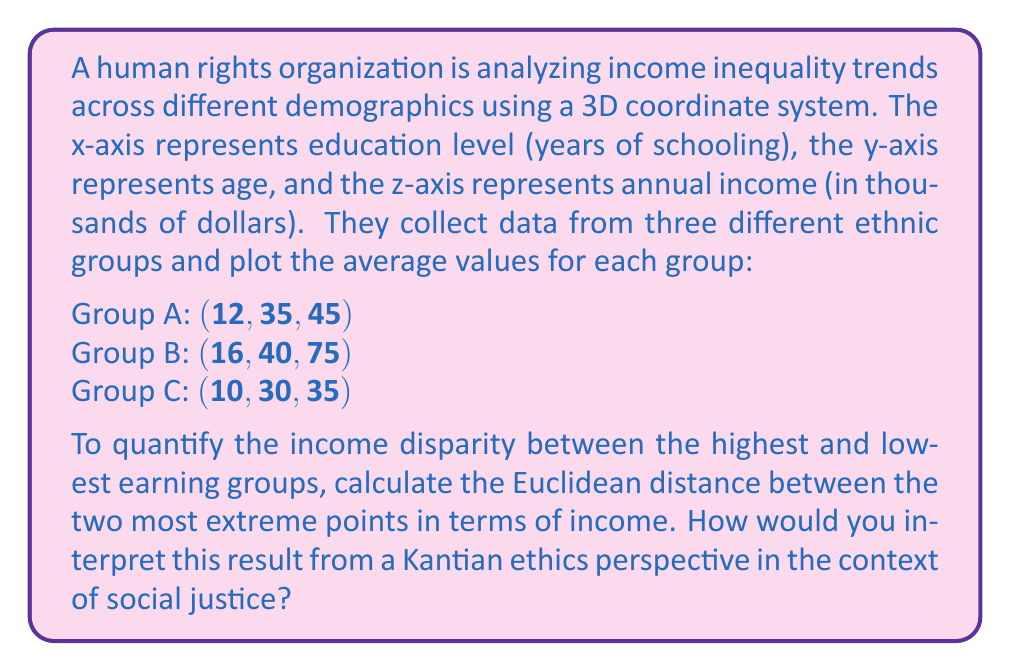Provide a solution to this math problem. To solve this problem, we need to follow these steps:

1. Identify the two most extreme points in terms of income (z-axis).
2. Calculate the Euclidean distance between these points.
3. Interpret the result from a Kantian ethics perspective.

Step 1: Identifying the extreme points
The highest income is for Group B at $75,000, and the lowest is for Group C at $35,000.

Step 2: Calculating the Euclidean distance
The Euclidean distance in 3D space is given by the formula:

$$d = \sqrt{(x_2-x_1)^2 + (y_2-y_1)^2 + (z_2-z_1)^2}$$

Where $(x_1, y_1, z_1)$ is the first point and $(x_2, y_2, z_2)$ is the second point.

Substituting the values:
$$(x_1, y_1, z_1) = (10, 30, 35)$$ (Group C)
$$(x_2, y_2, z_2) = (16, 40, 75)$$ (Group B)

$$d = \sqrt{(16-10)^2 + (40-30)^2 + (75-35)^2}$$
$$d = \sqrt{6^2 + 10^2 + 40^2}$$
$$d = \sqrt{36 + 100 + 1600}$$
$$d = \sqrt{1736}$$
$$d \approx 41.67$$

Step 3: Interpretation
The Euclidean distance of approximately 41.67 represents the overall disparity between the two groups, considering not just income, but also education and age. This multidimensional approach aligns with Kantian ethics, which emphasizes treating people as ends in themselves and not merely as means.

From a Kantian perspective, this disparity raises concerns about equal dignity and respect for all individuals. The categorical imperative would suggest that a just society should strive for more equitable outcomes across all demographics. The significant distance between these groups indicates a potential violation of the principle of universalizability, as we wouldn't will such inequality to be a universal law.

Moreover, the disparity in education (6 years) contributing to this distance highlights the importance of equal access to education as a means of addressing income inequality, which aligns with Kant's emphasis on rationality and autonomy.
Answer: The Euclidean distance between the highest and lowest earning groups is approximately 41.67 units. This value represents the multidimensional disparity in income, education, and age between these groups, raising significant concerns from a Kantian ethics perspective about equal dignity, respect, and the universalizability of such inequality in a just society. 